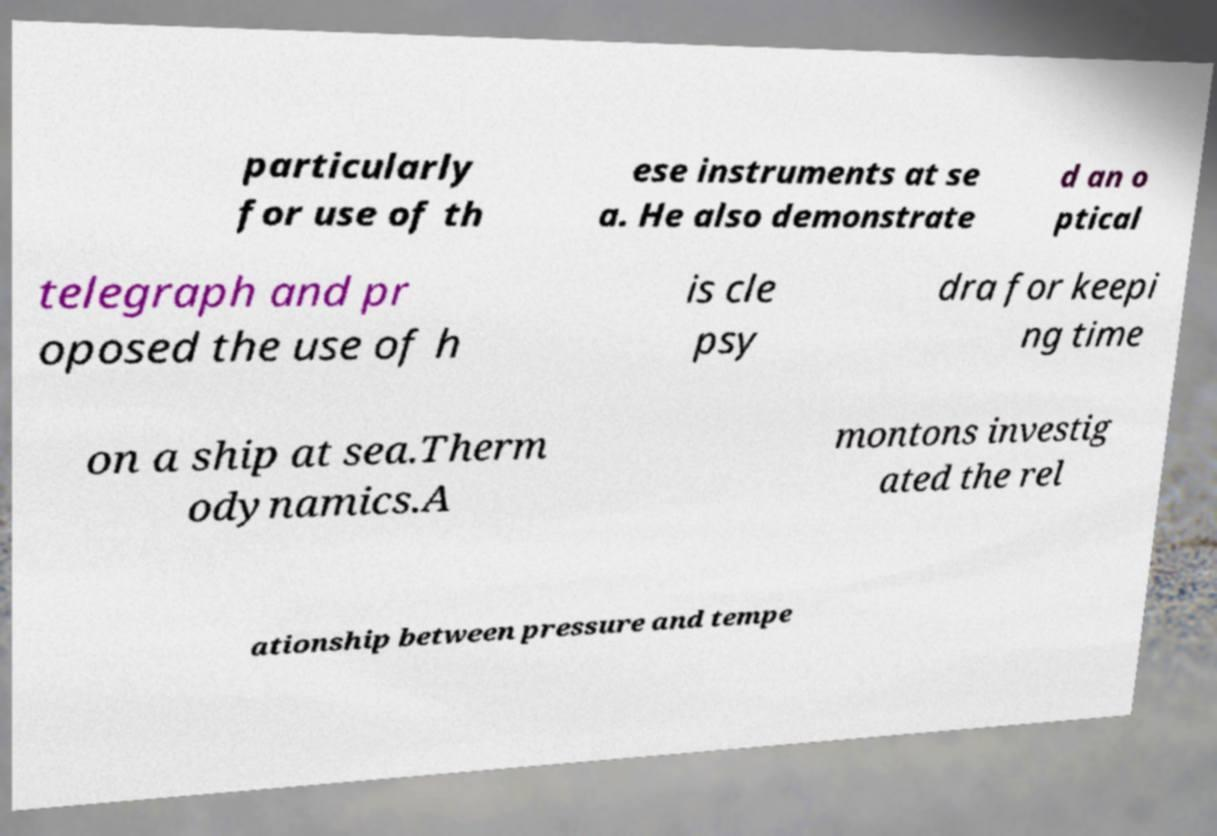Please identify and transcribe the text found in this image. particularly for use of th ese instruments at se a. He also demonstrate d an o ptical telegraph and pr oposed the use of h is cle psy dra for keepi ng time on a ship at sea.Therm odynamics.A montons investig ated the rel ationship between pressure and tempe 